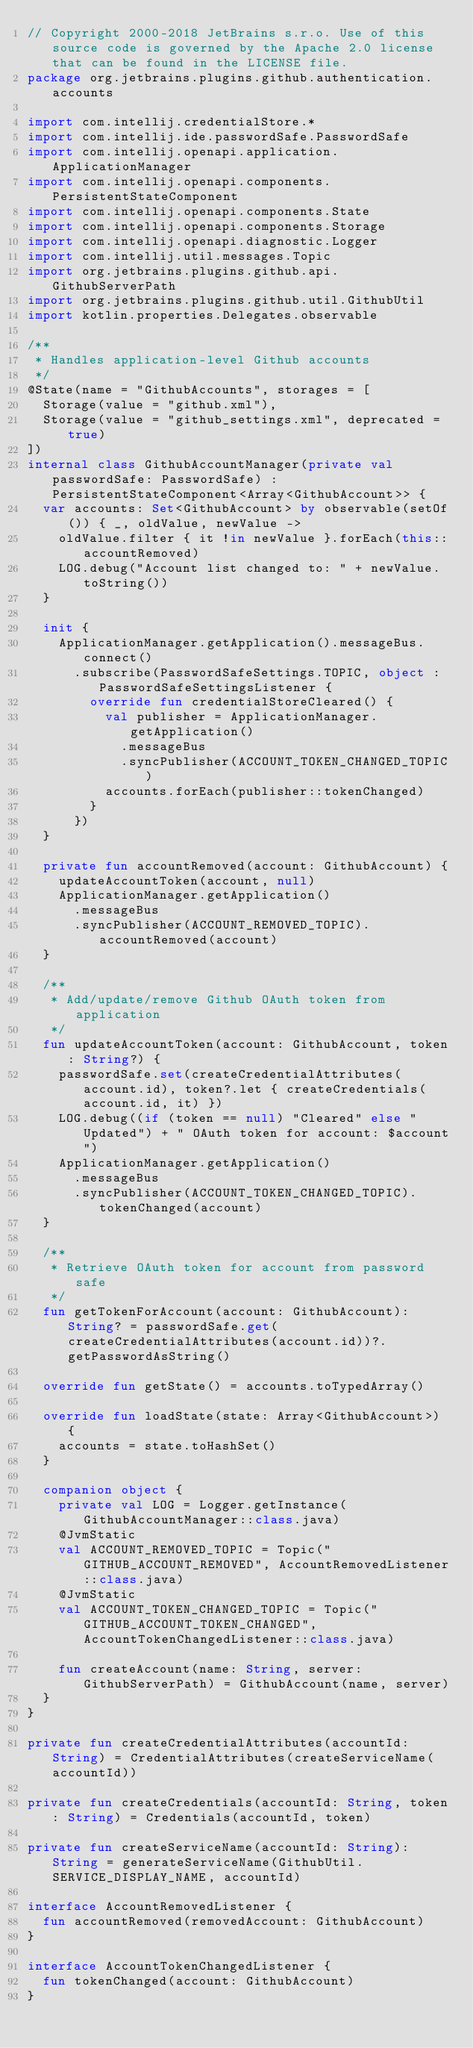<code> <loc_0><loc_0><loc_500><loc_500><_Kotlin_>// Copyright 2000-2018 JetBrains s.r.o. Use of this source code is governed by the Apache 2.0 license that can be found in the LICENSE file.
package org.jetbrains.plugins.github.authentication.accounts

import com.intellij.credentialStore.*
import com.intellij.ide.passwordSafe.PasswordSafe
import com.intellij.openapi.application.ApplicationManager
import com.intellij.openapi.components.PersistentStateComponent
import com.intellij.openapi.components.State
import com.intellij.openapi.components.Storage
import com.intellij.openapi.diagnostic.Logger
import com.intellij.util.messages.Topic
import org.jetbrains.plugins.github.api.GithubServerPath
import org.jetbrains.plugins.github.util.GithubUtil
import kotlin.properties.Delegates.observable

/**
 * Handles application-level Github accounts
 */
@State(name = "GithubAccounts", storages = [
  Storage(value = "github.xml"),
  Storage(value = "github_settings.xml", deprecated = true)
])
internal class GithubAccountManager(private val passwordSafe: PasswordSafe) : PersistentStateComponent<Array<GithubAccount>> {
  var accounts: Set<GithubAccount> by observable(setOf()) { _, oldValue, newValue ->
    oldValue.filter { it !in newValue }.forEach(this::accountRemoved)
    LOG.debug("Account list changed to: " + newValue.toString())
  }

  init {
    ApplicationManager.getApplication().messageBus.connect()
      .subscribe(PasswordSafeSettings.TOPIC, object : PasswordSafeSettingsListener {
        override fun credentialStoreCleared() {
          val publisher = ApplicationManager.getApplication()
            .messageBus
            .syncPublisher(ACCOUNT_TOKEN_CHANGED_TOPIC)
          accounts.forEach(publisher::tokenChanged)
        }
      })
  }

  private fun accountRemoved(account: GithubAccount) {
    updateAccountToken(account, null)
    ApplicationManager.getApplication()
      .messageBus
      .syncPublisher(ACCOUNT_REMOVED_TOPIC).accountRemoved(account)
  }

  /**
   * Add/update/remove Github OAuth token from application
   */
  fun updateAccountToken(account: GithubAccount, token: String?) {
    passwordSafe.set(createCredentialAttributes(account.id), token?.let { createCredentials(account.id, it) })
    LOG.debug((if (token == null) "Cleared" else "Updated") + " OAuth token for account: $account")
    ApplicationManager.getApplication()
      .messageBus
      .syncPublisher(ACCOUNT_TOKEN_CHANGED_TOPIC).tokenChanged(account)
  }

  /**
   * Retrieve OAuth token for account from password safe
   */
  fun getTokenForAccount(account: GithubAccount): String? = passwordSafe.get(createCredentialAttributes(account.id))?.getPasswordAsString()

  override fun getState() = accounts.toTypedArray()

  override fun loadState(state: Array<GithubAccount>) {
    accounts = state.toHashSet()
  }

  companion object {
    private val LOG = Logger.getInstance(GithubAccountManager::class.java)
    @JvmStatic
    val ACCOUNT_REMOVED_TOPIC = Topic("GITHUB_ACCOUNT_REMOVED", AccountRemovedListener::class.java)
    @JvmStatic
    val ACCOUNT_TOKEN_CHANGED_TOPIC = Topic("GITHUB_ACCOUNT_TOKEN_CHANGED", AccountTokenChangedListener::class.java)

    fun createAccount(name: String, server: GithubServerPath) = GithubAccount(name, server)
  }
}

private fun createCredentialAttributes(accountId: String) = CredentialAttributes(createServiceName(accountId))

private fun createCredentials(accountId: String, token: String) = Credentials(accountId, token)

private fun createServiceName(accountId: String): String = generateServiceName(GithubUtil.SERVICE_DISPLAY_NAME, accountId)

interface AccountRemovedListener {
  fun accountRemoved(removedAccount: GithubAccount)
}

interface AccountTokenChangedListener {
  fun tokenChanged(account: GithubAccount)
}</code> 